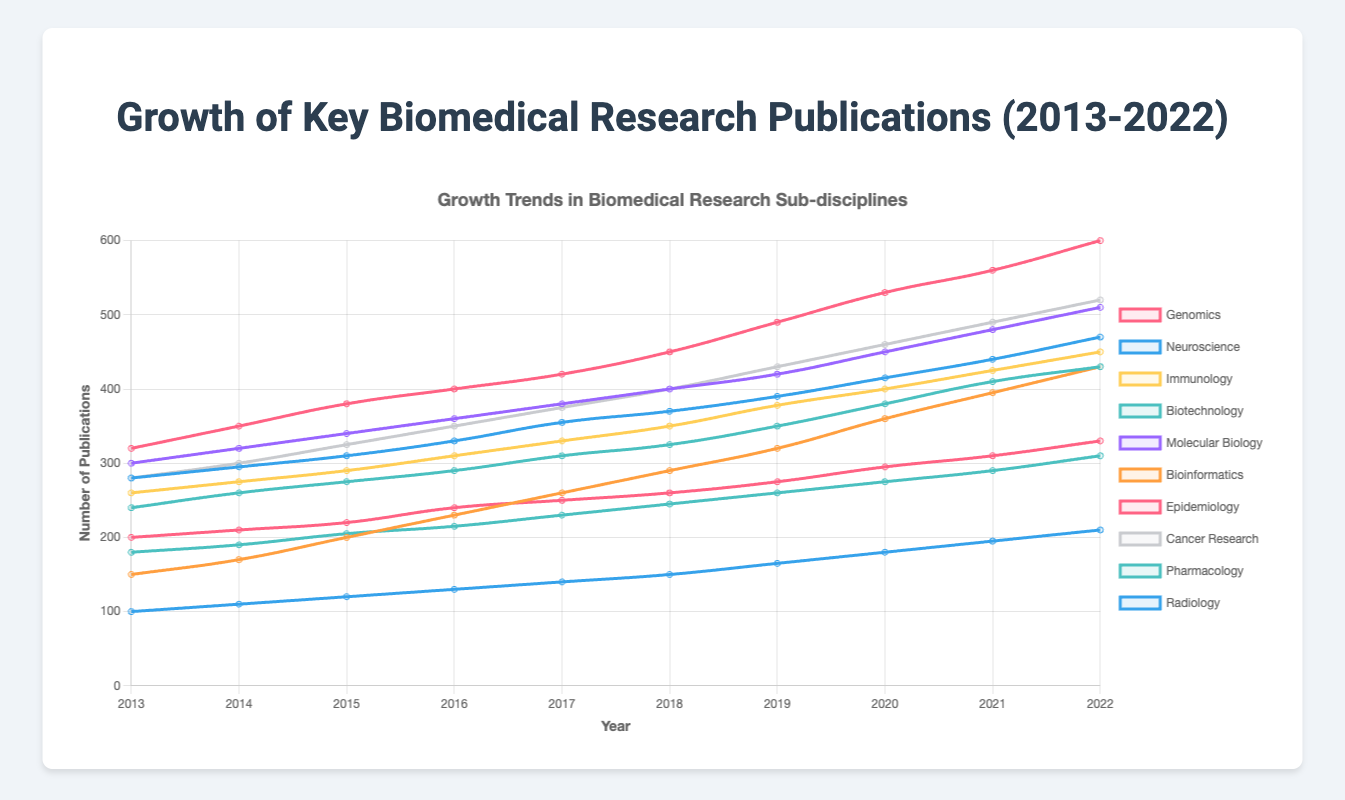What is the trend of Genomics publications from 2013 to 2022? The number of Genomics publications started at 320 in 2013 and increased steadily each year to reach 600 in 2022.
Answer: Steady increase Which sub-discipline had the highest number of publications in 2022? To find the sub-discipline with the highest number of publications in 2022, we compare the values for each sub-discipline: Genomics (600), Neuroscience (470), Immunology (450), Biotechnology (430), Molecular Biology (510), Bioinformatics (430), Epidemiology (330), Cancer Research (520), Pharmacology (310), and Radiology (210). The highest is Genomics with 600 publications.
Answer: Genomics How did the number of Bioinformatics publications change between 2013 and 2022? The number of Bioinformatics publications increased from 150 in 2013 to 430 in 2022, showing a rapid and steady growth over the decade.
Answer: Rapid increase In which year did Cancer Research publications reach 400? By examining the Cancer Research data, we see the number of publications reaches 400 in the year 2018.
Answer: 2018 Which sub-discipline had the least publications in 2013 and what was the number? From the data given, Radiology had the least number of publications in 2013, with only 100 publications.
Answer: Radiology, 100 Compare the number of publications in Biotechnology and Epidemiology in 2022. Which is greater and by how much? In 2022, Biotechnology had 430 publications and Epidemiology had 330 publications. The difference is 430 - 330 = 100 publications, with Biotechnology having more.
Answer: Biotechnology by 100 What is the average number of publications for Molecular Biology over the decade? To calculate the average, sum the values from each year and divide by the number of years, (300 + 320 + 340 + 360 + 380 + 400 + 420 + 450 + 480 + 510) = 3960; average = 3960 / 10 = 396.
Answer: 396 How much did Immunology publications grow from 2016 to 2020? In 2016, Immunology had 310 publications. By 2020, it had 400. The growth is 400 - 310 = 90 publications.
Answer: 90 Which sub-discipline shows the most consistent growth? By visual inspection, Genomics shows a very consistent and steady increase each year, highlighting a linear growth trend.
Answer: Genomics Which sub-discipline has the steepest increase in publications between 2019 and 2020? Comparing the growth rate from 2019 to 2020 for all sub-disciplines, Bioinformatics has the steepest increase going from 320 to 360, which is an increase of 40 publications.
Answer: Bioinformatics 